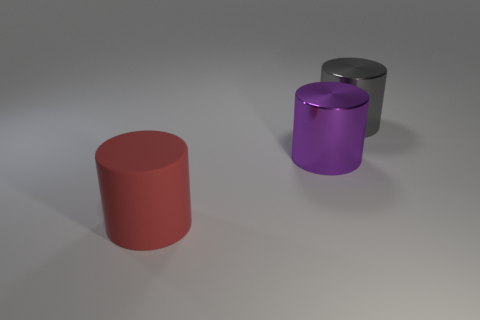How many gray shiny objects have the same shape as the big purple object? 1 